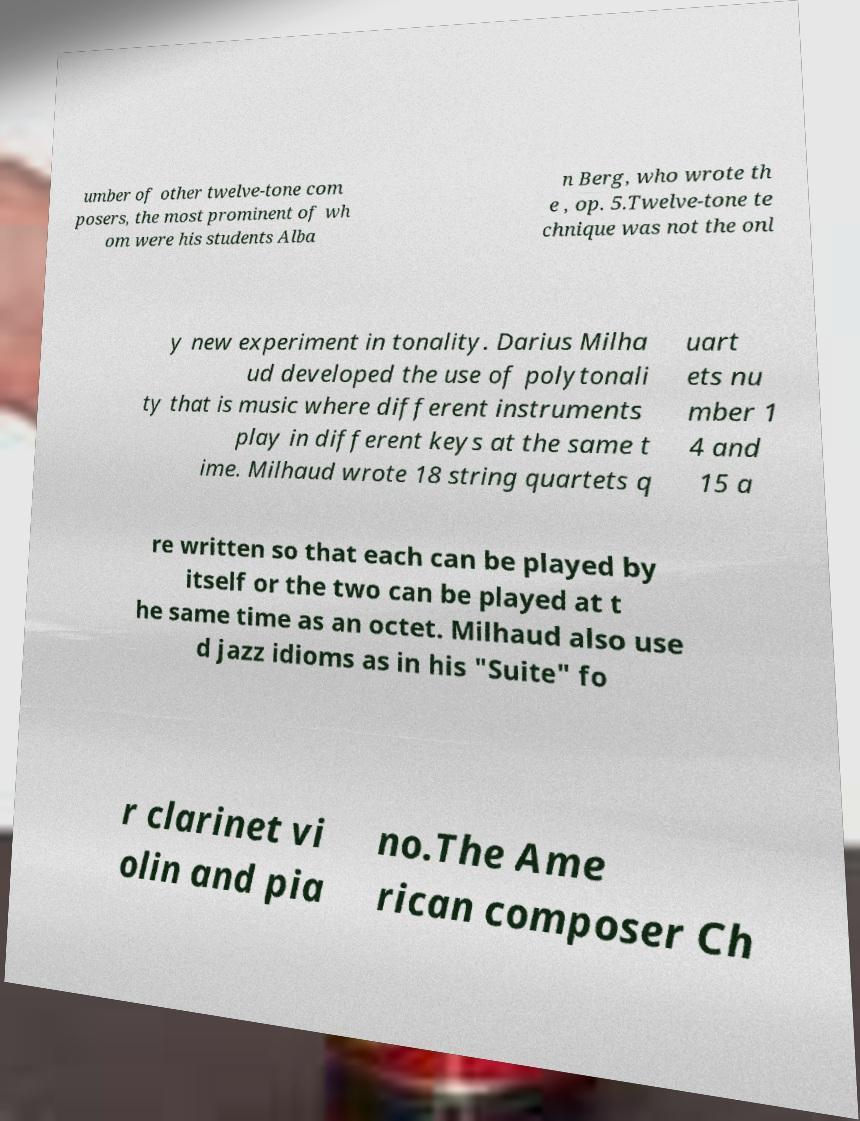Could you assist in decoding the text presented in this image and type it out clearly? umber of other twelve-tone com posers, the most prominent of wh om were his students Alba n Berg, who wrote th e , op. 5.Twelve-tone te chnique was not the onl y new experiment in tonality. Darius Milha ud developed the use of polytonali ty that is music where different instruments play in different keys at the same t ime. Milhaud wrote 18 string quartets q uart ets nu mber 1 4 and 15 a re written so that each can be played by itself or the two can be played at t he same time as an octet. Milhaud also use d jazz idioms as in his "Suite" fo r clarinet vi olin and pia no.The Ame rican composer Ch 